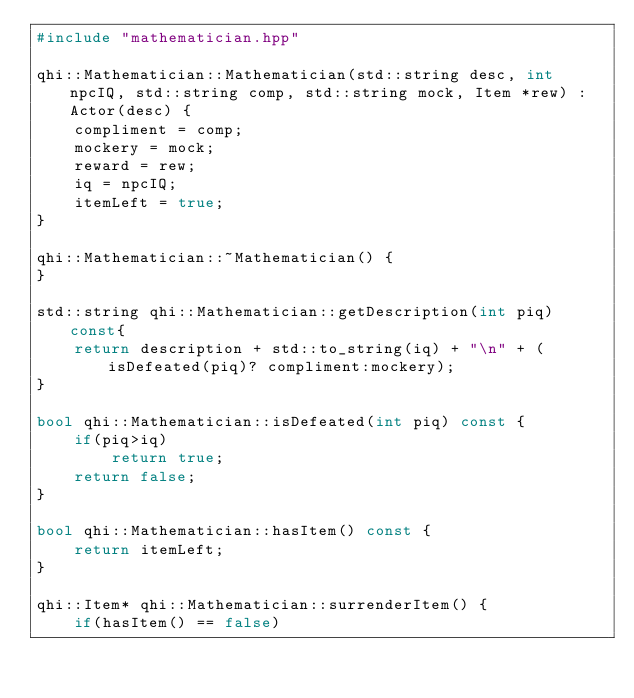<code> <loc_0><loc_0><loc_500><loc_500><_C++_>#include "mathematician.hpp"

qhi::Mathematician::Mathematician(std::string desc, int npcIQ, std::string comp, std::string mock, Item *rew) : Actor(desc) {
	compliment = comp;
	mockery = mock;
	reward = rew;
	iq = npcIQ;
	itemLeft = true;
}

qhi::Mathematician::~Mathematician() {
}

std::string qhi::Mathematician::getDescription(int piq) const{
	return description + std::to_string(iq) + "\n" + (isDefeated(piq)? compliment:mockery);
}

bool qhi::Mathematician::isDefeated(int piq) const {
	if(piq>iq)
		return true;
	return false;
}

bool qhi::Mathematician::hasItem() const {
	return itemLeft;
}

qhi::Item* qhi::Mathematician::surrenderItem() {
	if(hasItem() == false)</code> 